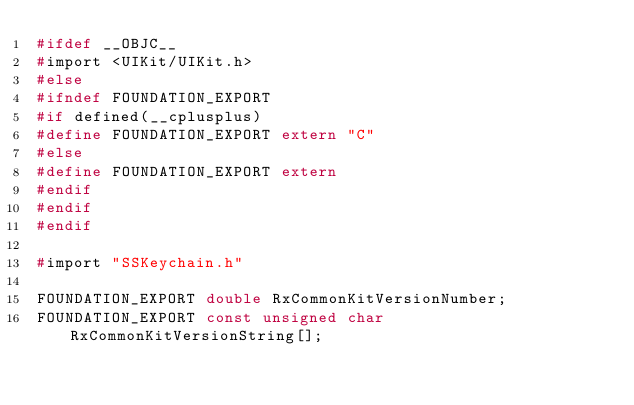Convert code to text. <code><loc_0><loc_0><loc_500><loc_500><_C_>#ifdef __OBJC__
#import <UIKit/UIKit.h>
#else
#ifndef FOUNDATION_EXPORT
#if defined(__cplusplus)
#define FOUNDATION_EXPORT extern "C"
#else
#define FOUNDATION_EXPORT extern
#endif
#endif
#endif

#import "SSKeychain.h"

FOUNDATION_EXPORT double RxCommonKitVersionNumber;
FOUNDATION_EXPORT const unsigned char RxCommonKitVersionString[];

</code> 